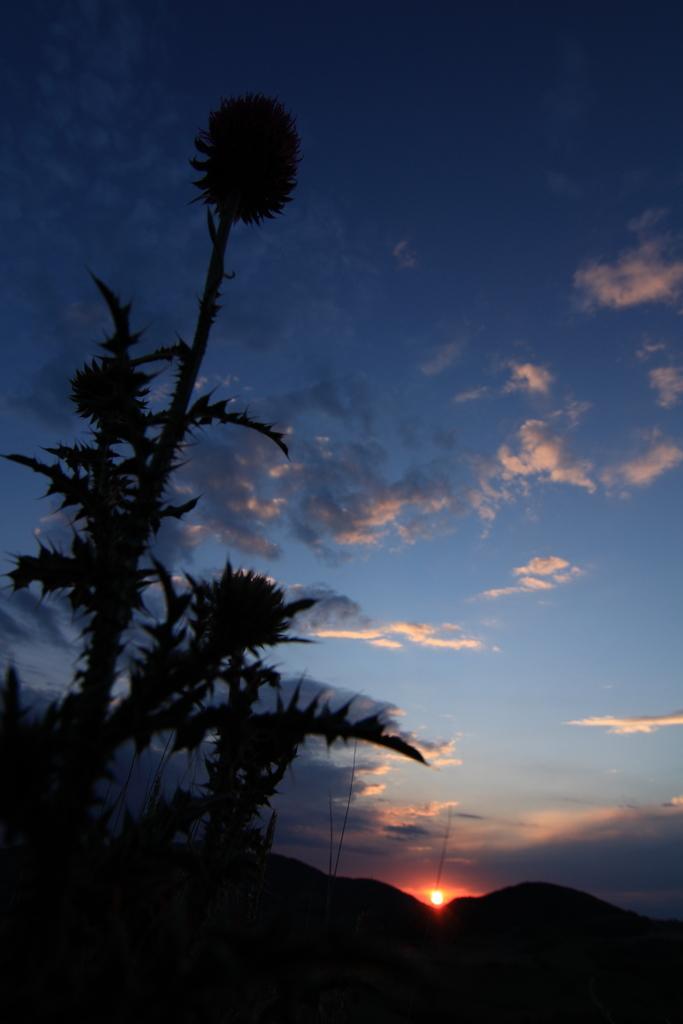Could you give a brief overview of what you see in this image? In this picture, we can see the ground, plants, and the sky with clouds, and sun. 